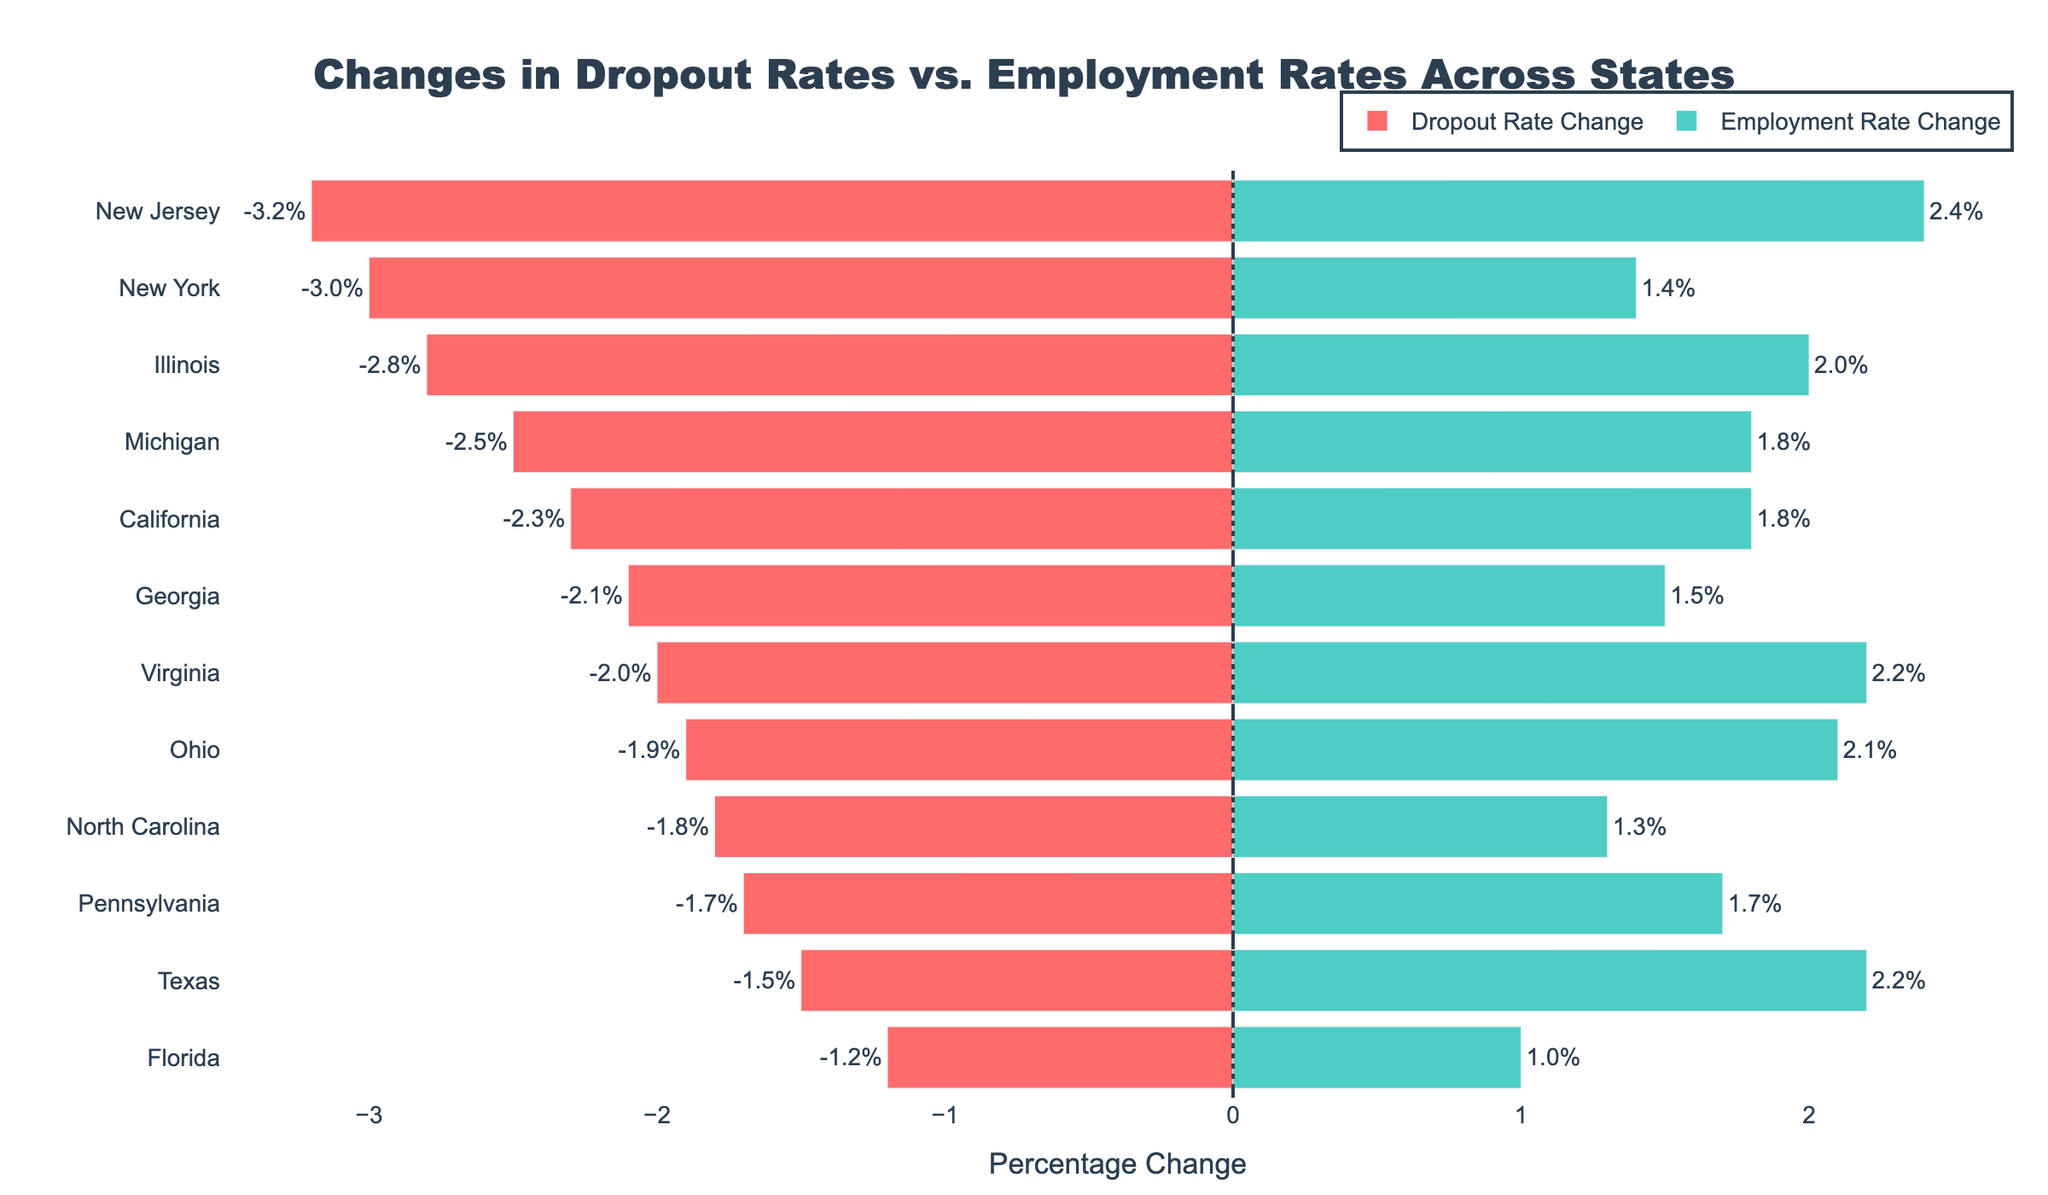What state has the largest decrease in dropout rate? By observing the length of the red bars for dropout rate changes, we can see that New Jersey has the longest red bar extending to -3.2%, indicating the largest decrease in dropout rate.
Answer: New Jersey Which state experienced the smallest change in both dropout and employment rates? By comparing the lengths of both red and green bars, we see that Florida has the smallest absolute values for both rates: -1.2% for dropout and 1.0% for employment, indicating the smallest changes.
Answer: Florida What is the difference in employment rate change between the state with the highest and the lowest dropout rate change? New Jersey has the highest decrease in dropout rate (-3.2%), and Florida has the lowest (-1.2%). The employment rate change for New Jersey is 2.4%, and for Florida, it is 1.0%. The difference is 2.4% - 1.0% = 1.4%.
Answer: 1.4% Which states have an employment rate change greater than 2.0%? By examining the green bars, we see that Texas, Illinois, New Jersey, and Virginia have employment rate changes of 2.2%, 2.0%, 2.4%, and 2.2%, respectively, all greater than 2.0%.
Answer: Texas, Illinois, New Jersey, Virginia Is there a direct correlation between the changes in dropout and employment rates? From the visual distribution of the red and green bars, it is observed that states with higher dropout rate decreases do not consistently have the highest employment rate increases, indicating no clear direct correlation.
Answer: No Which state shows a better balance between reducing dropout rates and increasing employment rates? By comparing both bar lengths, New Jersey shows a significant reduction in dropout rate (-3.2%) and a considerable increase in employment rate (2.4%), suggesting a balanced improvement in both metrics.
Answer: New Jersey How many states have a dropout rate decrease between -2.0% and -3.0%? By counting the red bars falling within the -2.0% to -3.0% range, we identify California, Illinois, Ohio, Georgia, and Virginia, making a total of 5 states.
Answer: 5 Compare the changes in Ohio and Georgia in terms of dropout and employment rates. Ohio has a dropout rate change of -1.9% and an employment rate change of 2.1%. Georgia has a dropout rate change of -2.1% and an employment rate change of 1.5%. Ohio's employment rate change is higher, but Georgia has a slightly larger decrease in dropout rate.
Answer: Ohio: -1.9% and 2.1%; Georgia: -2.1% and 1.5% How many states have both a decrease in dropout rates and an increase in employment rates? By observing the direction of both red and green bars, we notice that all 12 listed states exhibit both a decrease in dropout rates and an increase in employment rates.
Answer: 12 states 